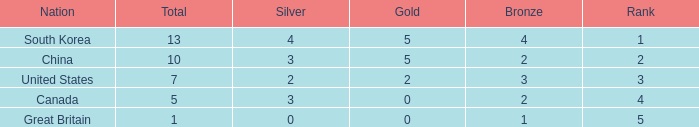What is the total number of Gold, when Silver is 2, and when Total is less than 7? 0.0. 